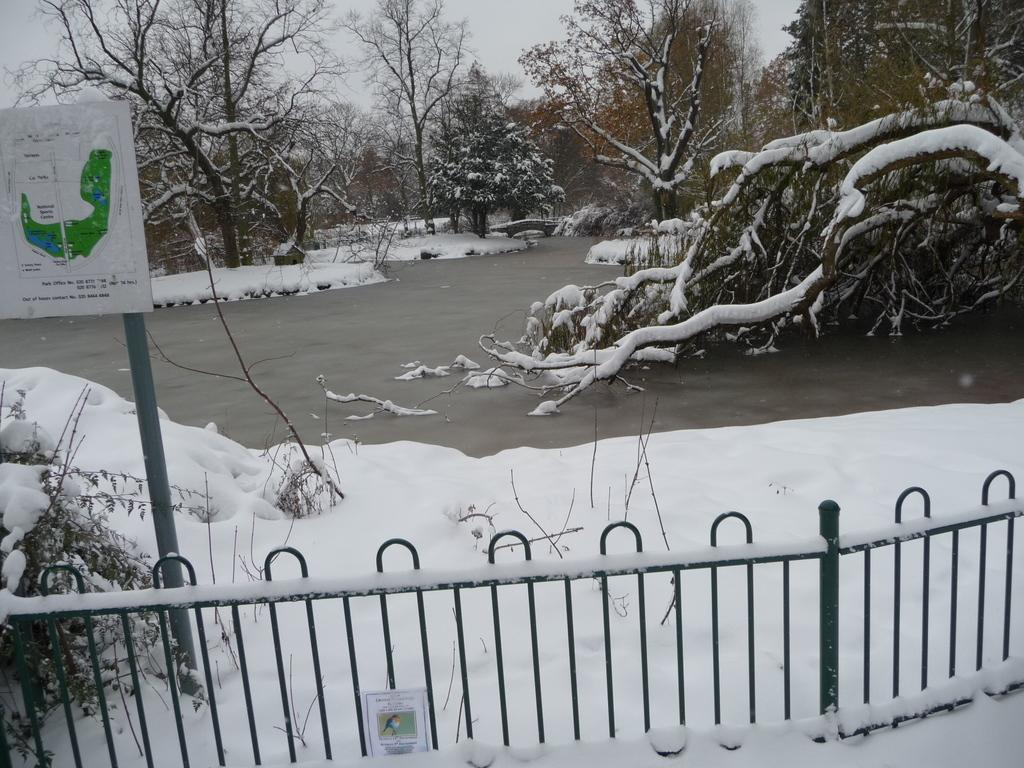What can be seen in the image that might be used for support or safety? There is a railing in the image that could be used for support or safety. What type of weather is depicted in the image? There is snow in the image, indicating cold weather. What is visible in the image that might be used for recreation or transportation? There is water visible in the image, which could be used for recreation or transportation. What is attached to a metal pole in the image? There is a board attached to a metal pole in the image. What type of natural environment is visible in the image? There are trees in the image, indicating a natural environment. What is visible in the background of the image? The sky is visible in the background of the image. Can you tell me how many toes are visible on the grandmother's foot in the image? There is no grandmother or foot present in the image; it features a railing, snow, water, a board attached to a metal pole, trees, and the sky. How many friends are visible in the image? There are no friends present in the image. 